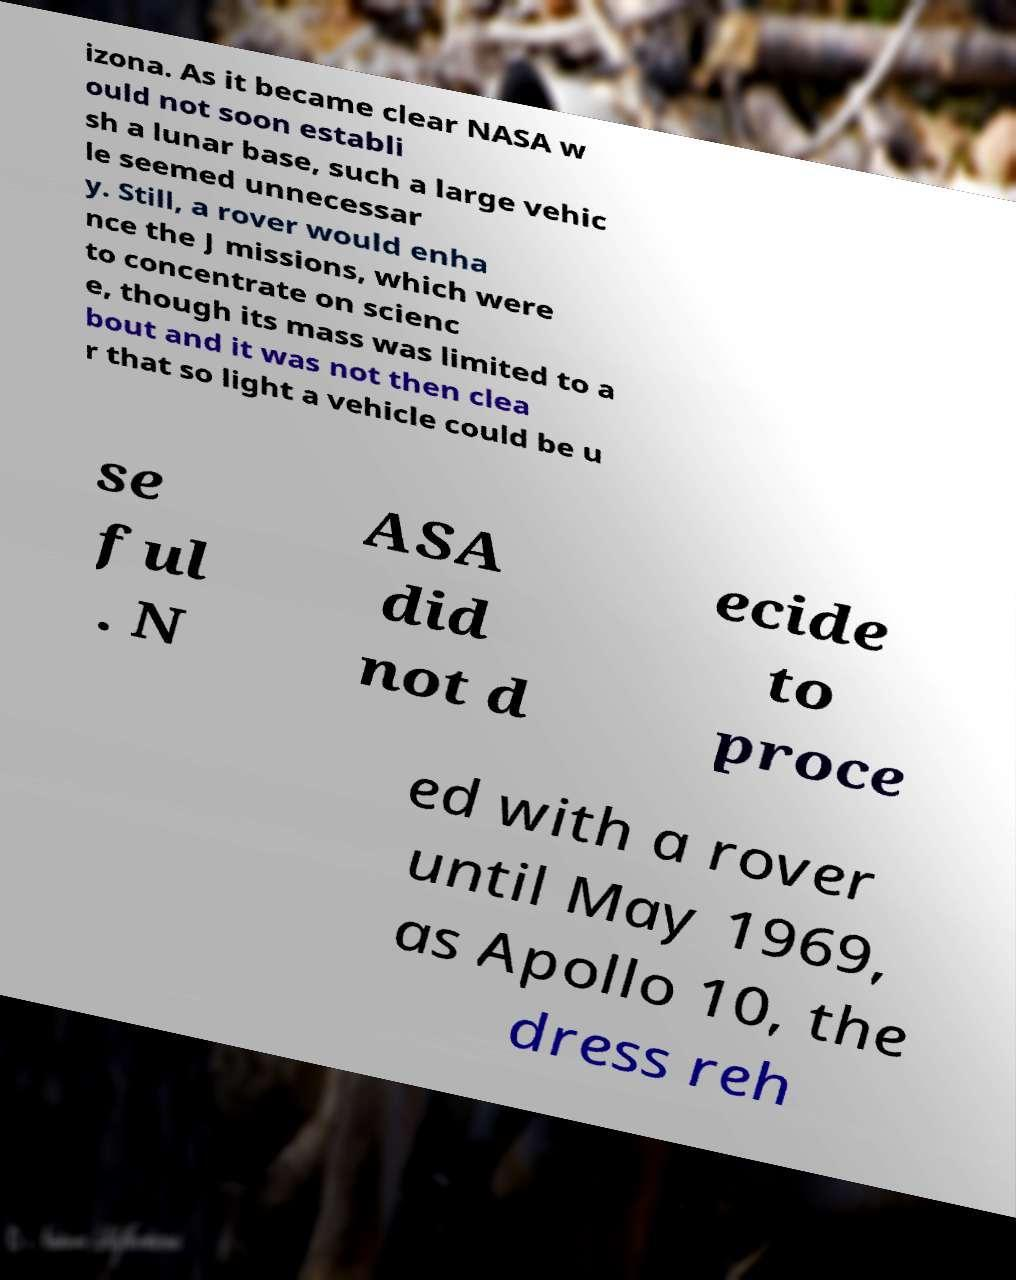Can you accurately transcribe the text from the provided image for me? izona. As it became clear NASA w ould not soon establi sh a lunar base, such a large vehic le seemed unnecessar y. Still, a rover would enha nce the J missions, which were to concentrate on scienc e, though its mass was limited to a bout and it was not then clea r that so light a vehicle could be u se ful . N ASA did not d ecide to proce ed with a rover until May 1969, as Apollo 10, the dress reh 